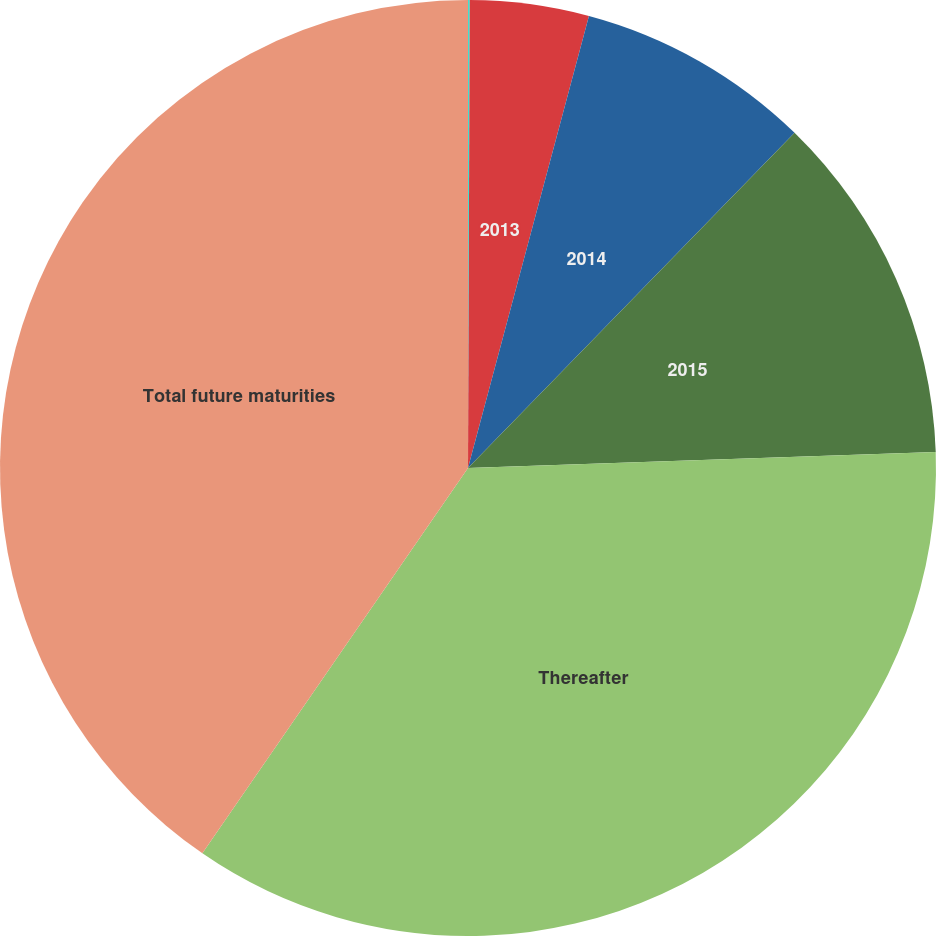Convert chart to OTSL. <chart><loc_0><loc_0><loc_500><loc_500><pie_chart><fcel>2012<fcel>2013<fcel>2014<fcel>2015<fcel>Thereafter<fcel>Total future maturities<nl><fcel>0.06%<fcel>4.1%<fcel>8.13%<fcel>12.16%<fcel>35.15%<fcel>40.39%<nl></chart> 